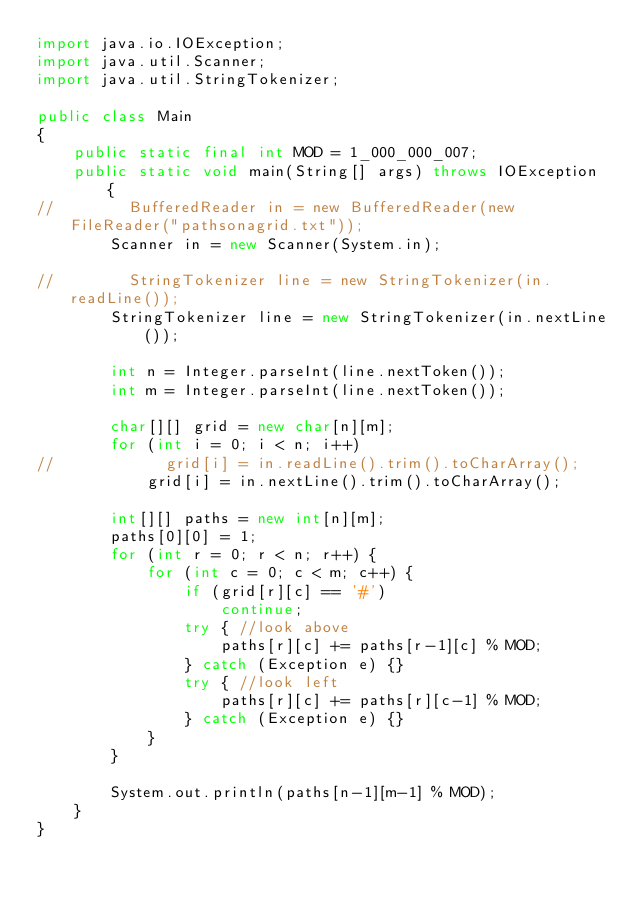<code> <loc_0><loc_0><loc_500><loc_500><_Java_>import java.io.IOException;
import java.util.Scanner;
import java.util.StringTokenizer;
 
public class Main
{
    public static final int MOD = 1_000_000_007;
    public static void main(String[] args) throws IOException {
//        BufferedReader in = new BufferedReader(new FileReader("pathsonagrid.txt"));
        Scanner in = new Scanner(System.in);
 
//        StringTokenizer line = new StringTokenizer(in.readLine());
        StringTokenizer line = new StringTokenizer(in.nextLine());
 
        int n = Integer.parseInt(line.nextToken());
        int m = Integer.parseInt(line.nextToken());
        
        char[][] grid = new char[n][m];
        for (int i = 0; i < n; i++)
//            grid[i] = in.readLine().trim().toCharArray();
            grid[i] = in.nextLine().trim().toCharArray();
        
        int[][] paths = new int[n][m];
        paths[0][0] = 1;
        for (int r = 0; r < n; r++) {
            for (int c = 0; c < m; c++) {
                if (grid[r][c] == '#')
                    continue;
                try { //look above
                    paths[r][c] += paths[r-1][c] % MOD;
                } catch (Exception e) {}
                try { //look left
                    paths[r][c] += paths[r][c-1] % MOD;
                } catch (Exception e) {}
            }
        }
        
        System.out.println(paths[n-1][m-1] % MOD);
    }
}</code> 